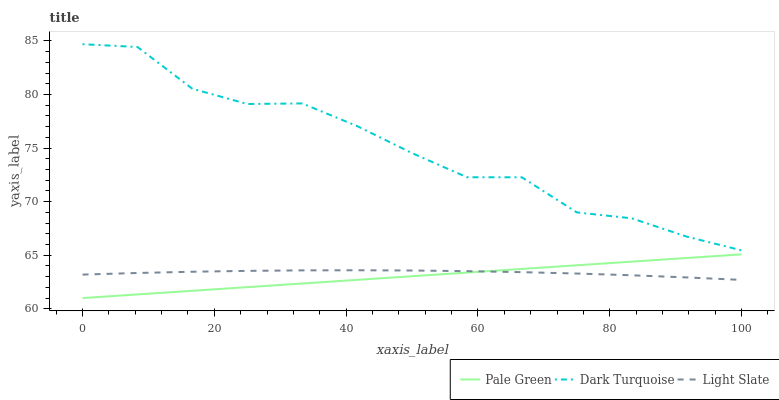Does Pale Green have the minimum area under the curve?
Answer yes or no. Yes. Does Dark Turquoise have the maximum area under the curve?
Answer yes or no. Yes. Does Dark Turquoise have the minimum area under the curve?
Answer yes or no. No. Does Pale Green have the maximum area under the curve?
Answer yes or no. No. Is Pale Green the smoothest?
Answer yes or no. Yes. Is Dark Turquoise the roughest?
Answer yes or no. Yes. Is Dark Turquoise the smoothest?
Answer yes or no. No. Is Pale Green the roughest?
Answer yes or no. No. Does Pale Green have the lowest value?
Answer yes or no. Yes. Does Dark Turquoise have the lowest value?
Answer yes or no. No. Does Dark Turquoise have the highest value?
Answer yes or no. Yes. Does Pale Green have the highest value?
Answer yes or no. No. Is Light Slate less than Dark Turquoise?
Answer yes or no. Yes. Is Dark Turquoise greater than Pale Green?
Answer yes or no. Yes. Does Light Slate intersect Pale Green?
Answer yes or no. Yes. Is Light Slate less than Pale Green?
Answer yes or no. No. Is Light Slate greater than Pale Green?
Answer yes or no. No. Does Light Slate intersect Dark Turquoise?
Answer yes or no. No. 